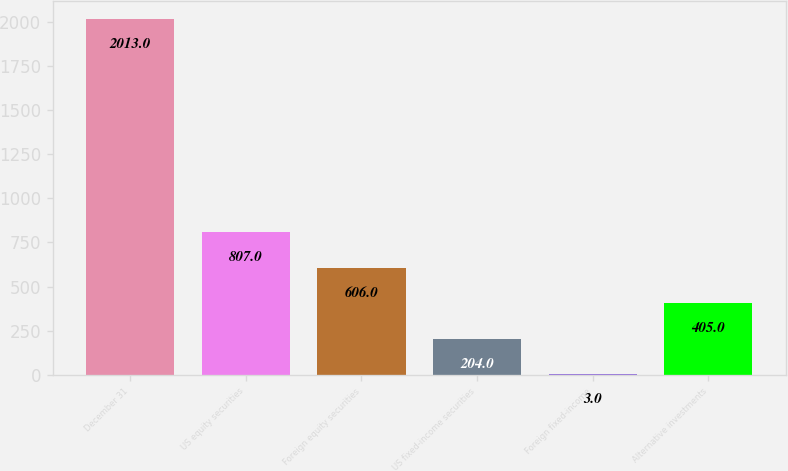Convert chart. <chart><loc_0><loc_0><loc_500><loc_500><bar_chart><fcel>December 31<fcel>US equity securities<fcel>Foreign equity securities<fcel>US fixed-income securities<fcel>Foreign fixed-income<fcel>Alternative investments<nl><fcel>2013<fcel>807<fcel>606<fcel>204<fcel>3<fcel>405<nl></chart> 